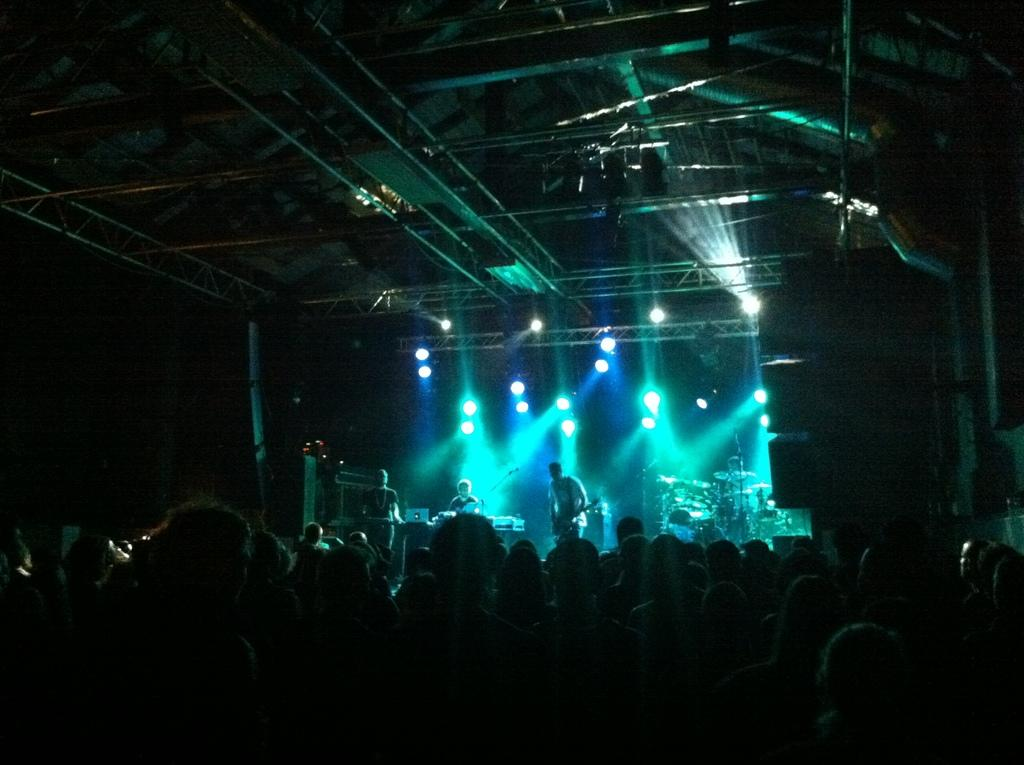What is the overall lighting condition in the image? The image is dark. Can you describe the people in the image? There are people in the image, but their specific actions or appearances are not mentioned in the facts. What is happening in the background of the image? There is a man playing guitar, and musical instruments are present in the background. What objects are visible in the image that are not related to the people or musical instruments? Lights are visible in the image, and there are rods at the top of the image. What type of grass can be seen growing in the field in the image? There is no grass or field present in the image; it is a dark scene with people, musical instruments, lights, and rods at the top. 